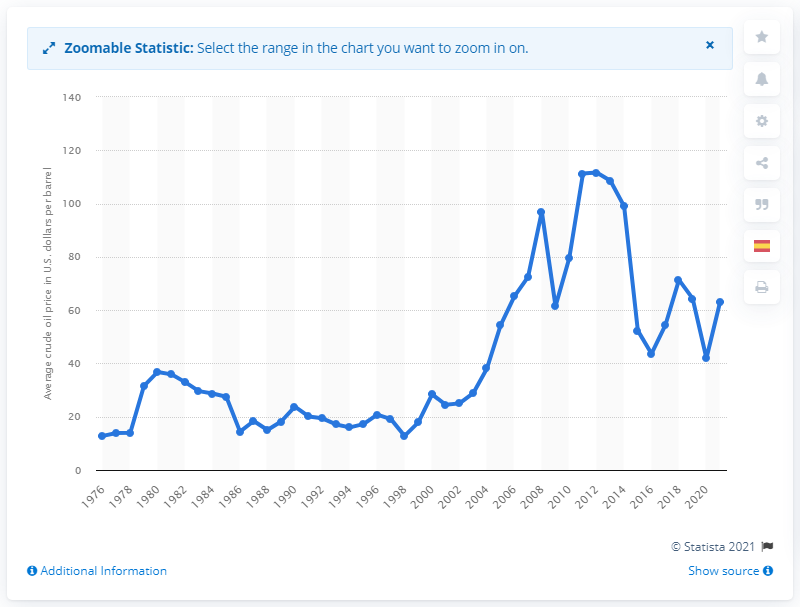Indicate a few pertinent items in this graphic. In 2021, the average price of Brent crude oil was 63.16 dollars per barrel. 